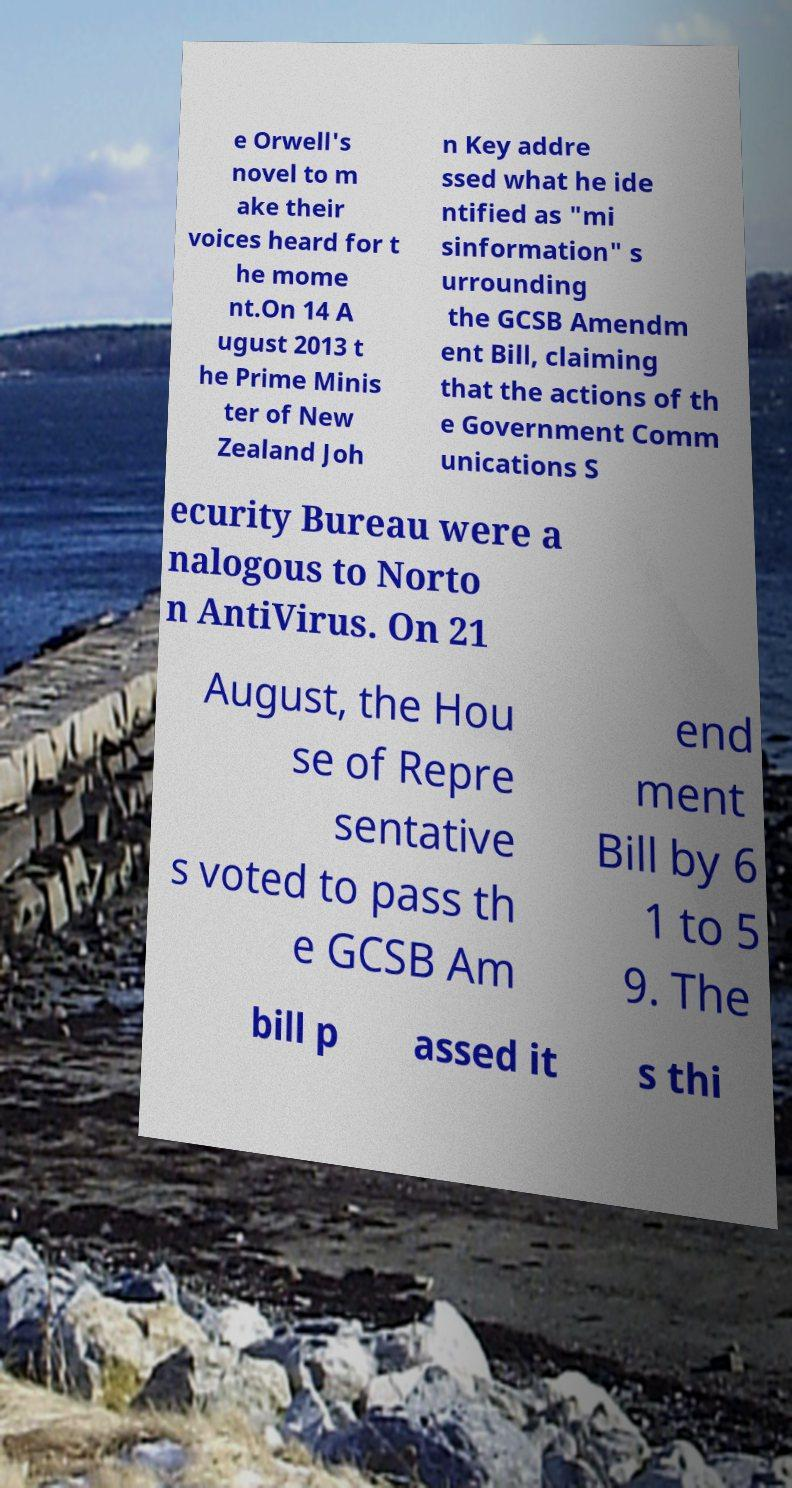Could you extract and type out the text from this image? e Orwell's novel to m ake their voices heard for t he mome nt.On 14 A ugust 2013 t he Prime Minis ter of New Zealand Joh n Key addre ssed what he ide ntified as "mi sinformation" s urrounding the GCSB Amendm ent Bill, claiming that the actions of th e Government Comm unications S ecurity Bureau were a nalogous to Norto n AntiVirus. On 21 August, the Hou se of Repre sentative s voted to pass th e GCSB Am end ment Bill by 6 1 to 5 9. The bill p assed it s thi 